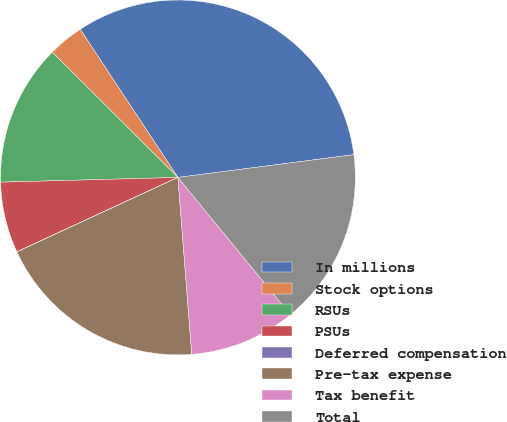<chart> <loc_0><loc_0><loc_500><loc_500><pie_chart><fcel>In millions<fcel>Stock options<fcel>RSUs<fcel>PSUs<fcel>Deferred compensation<fcel>Pre-tax expense<fcel>Tax benefit<fcel>Total<nl><fcel>32.24%<fcel>3.24%<fcel>12.9%<fcel>6.46%<fcel>0.01%<fcel>19.35%<fcel>9.68%<fcel>16.13%<nl></chart> 